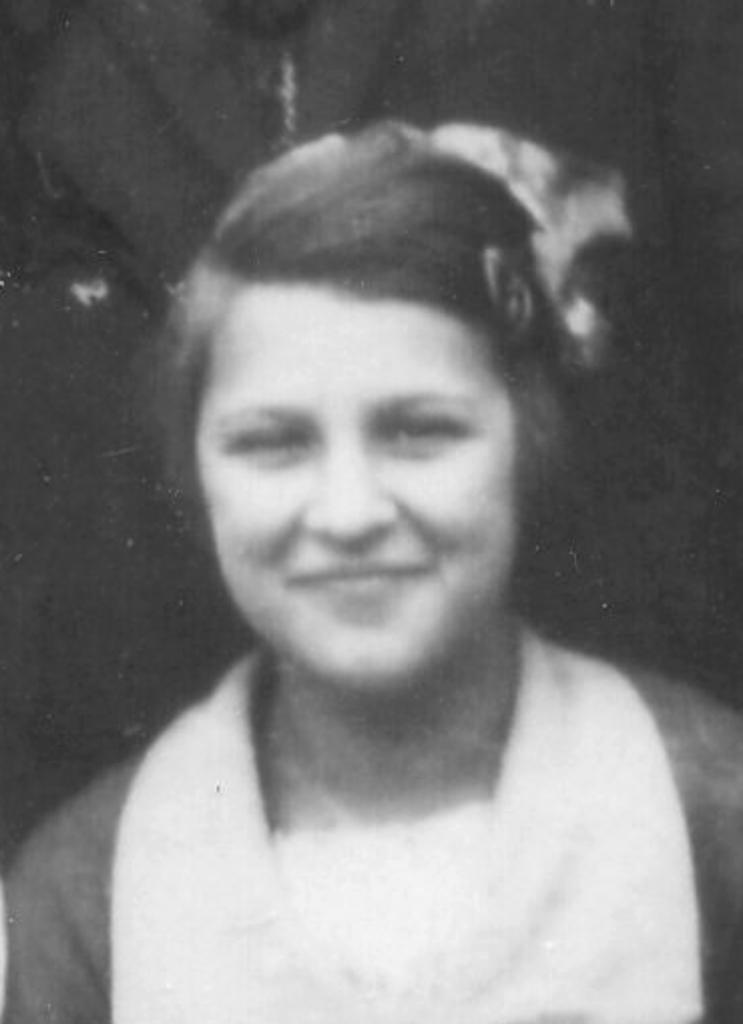What type of image is present in the picture? The image contains a black and white photograph. Who is the subject of the photograph? The photograph is of a woman. What is the woman doing in the photograph? The woman is smiling in the photograph. What type of map can be seen in the background of the photograph? There is no map present in the photograph; it is a black and white image of a woman smiling. Is there a fireman visible in the photograph? No, there is no fireman present in the photograph; it is a black and white image of a woman smiling. 